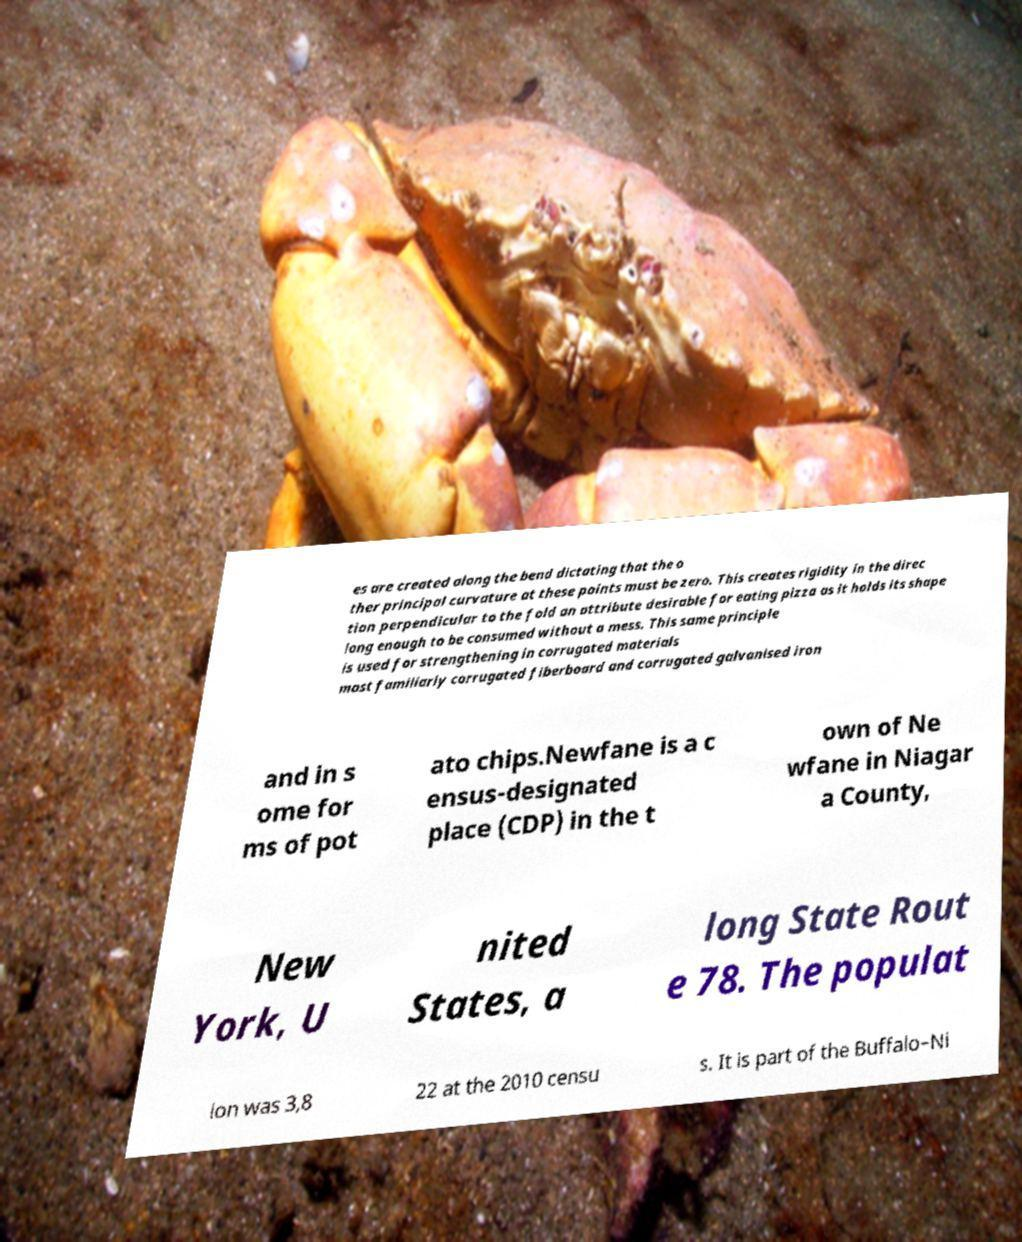Can you read and provide the text displayed in the image?This photo seems to have some interesting text. Can you extract and type it out for me? es are created along the bend dictating that the o ther principal curvature at these points must be zero. This creates rigidity in the direc tion perpendicular to the fold an attribute desirable for eating pizza as it holds its shape long enough to be consumed without a mess. This same principle is used for strengthening in corrugated materials most familiarly corrugated fiberboard and corrugated galvanised iron and in s ome for ms of pot ato chips.Newfane is a c ensus-designated place (CDP) in the t own of Ne wfane in Niagar a County, New York, U nited States, a long State Rout e 78. The populat ion was 3,8 22 at the 2010 censu s. It is part of the Buffalo–Ni 